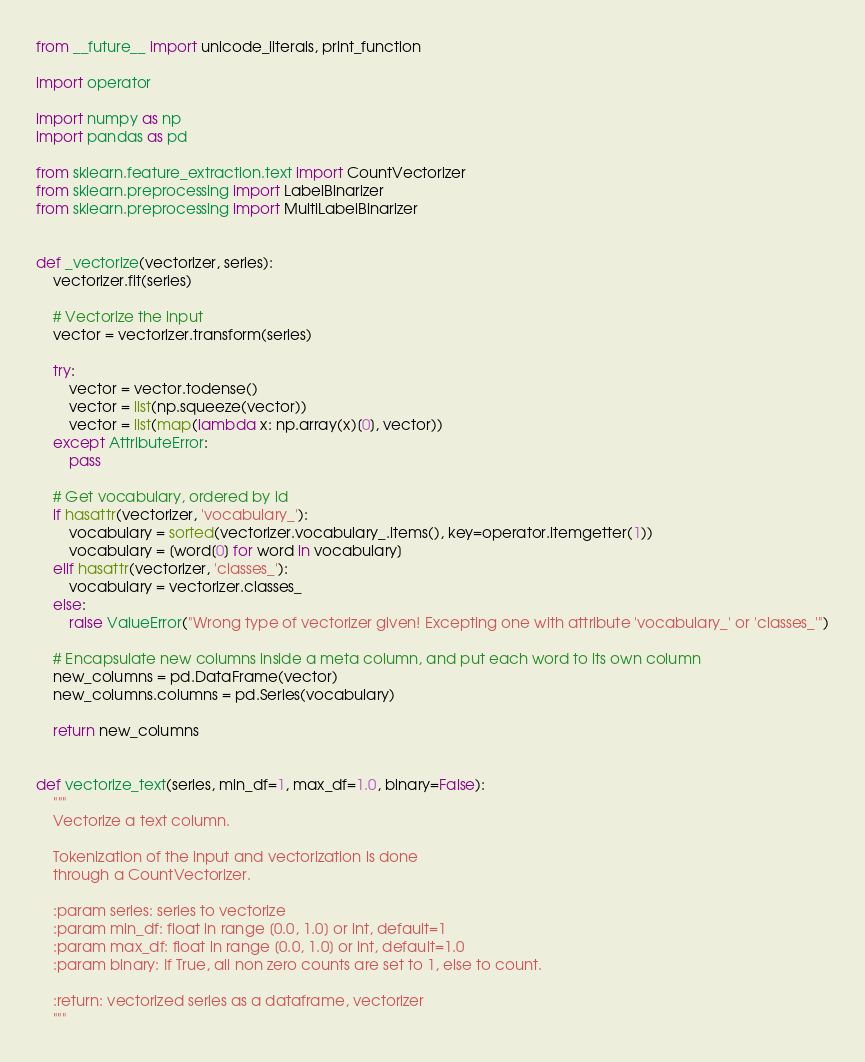Convert code to text. <code><loc_0><loc_0><loc_500><loc_500><_Python_>from __future__ import unicode_literals, print_function

import operator

import numpy as np
import pandas as pd

from sklearn.feature_extraction.text import CountVectorizer
from sklearn.preprocessing import LabelBinarizer
from sklearn.preprocessing import MultiLabelBinarizer


def _vectorize(vectorizer, series):
    vectorizer.fit(series)

    # Vectorize the input
    vector = vectorizer.transform(series)

    try:
        vector = vector.todense()
        vector = list(np.squeeze(vector))
        vector = list(map(lambda x: np.array(x)[0], vector))
    except AttributeError:
        pass

    # Get vocabulary, ordered by id
    if hasattr(vectorizer, 'vocabulary_'):
        vocabulary = sorted(vectorizer.vocabulary_.items(), key=operator.itemgetter(1))
        vocabulary = [word[0] for word in vocabulary]
    elif hasattr(vectorizer, 'classes_'):
        vocabulary = vectorizer.classes_
    else:
        raise ValueError("Wrong type of vectorizer given! Excepting one with attribute 'vocabulary_' or 'classes_'")

    # Encapsulate new columns inside a meta column, and put each word to its own column
    new_columns = pd.DataFrame(vector)
    new_columns.columns = pd.Series(vocabulary)

    return new_columns


def vectorize_text(series, min_df=1, max_df=1.0, binary=False):
    """
    Vectorize a text column.

    Tokenization of the input and vectorization is done
    through a CountVectorizer.

    :param series: series to vectorize
    :param min_df: float in range [0.0, 1.0] or int, default=1
    :param max_df: float in range [0.0, 1.0] or int, default=1.0
    :param binary: If True, all non zero counts are set to 1, else to count.

    :return: vectorized series as a dataframe, vectorizer
    """</code> 